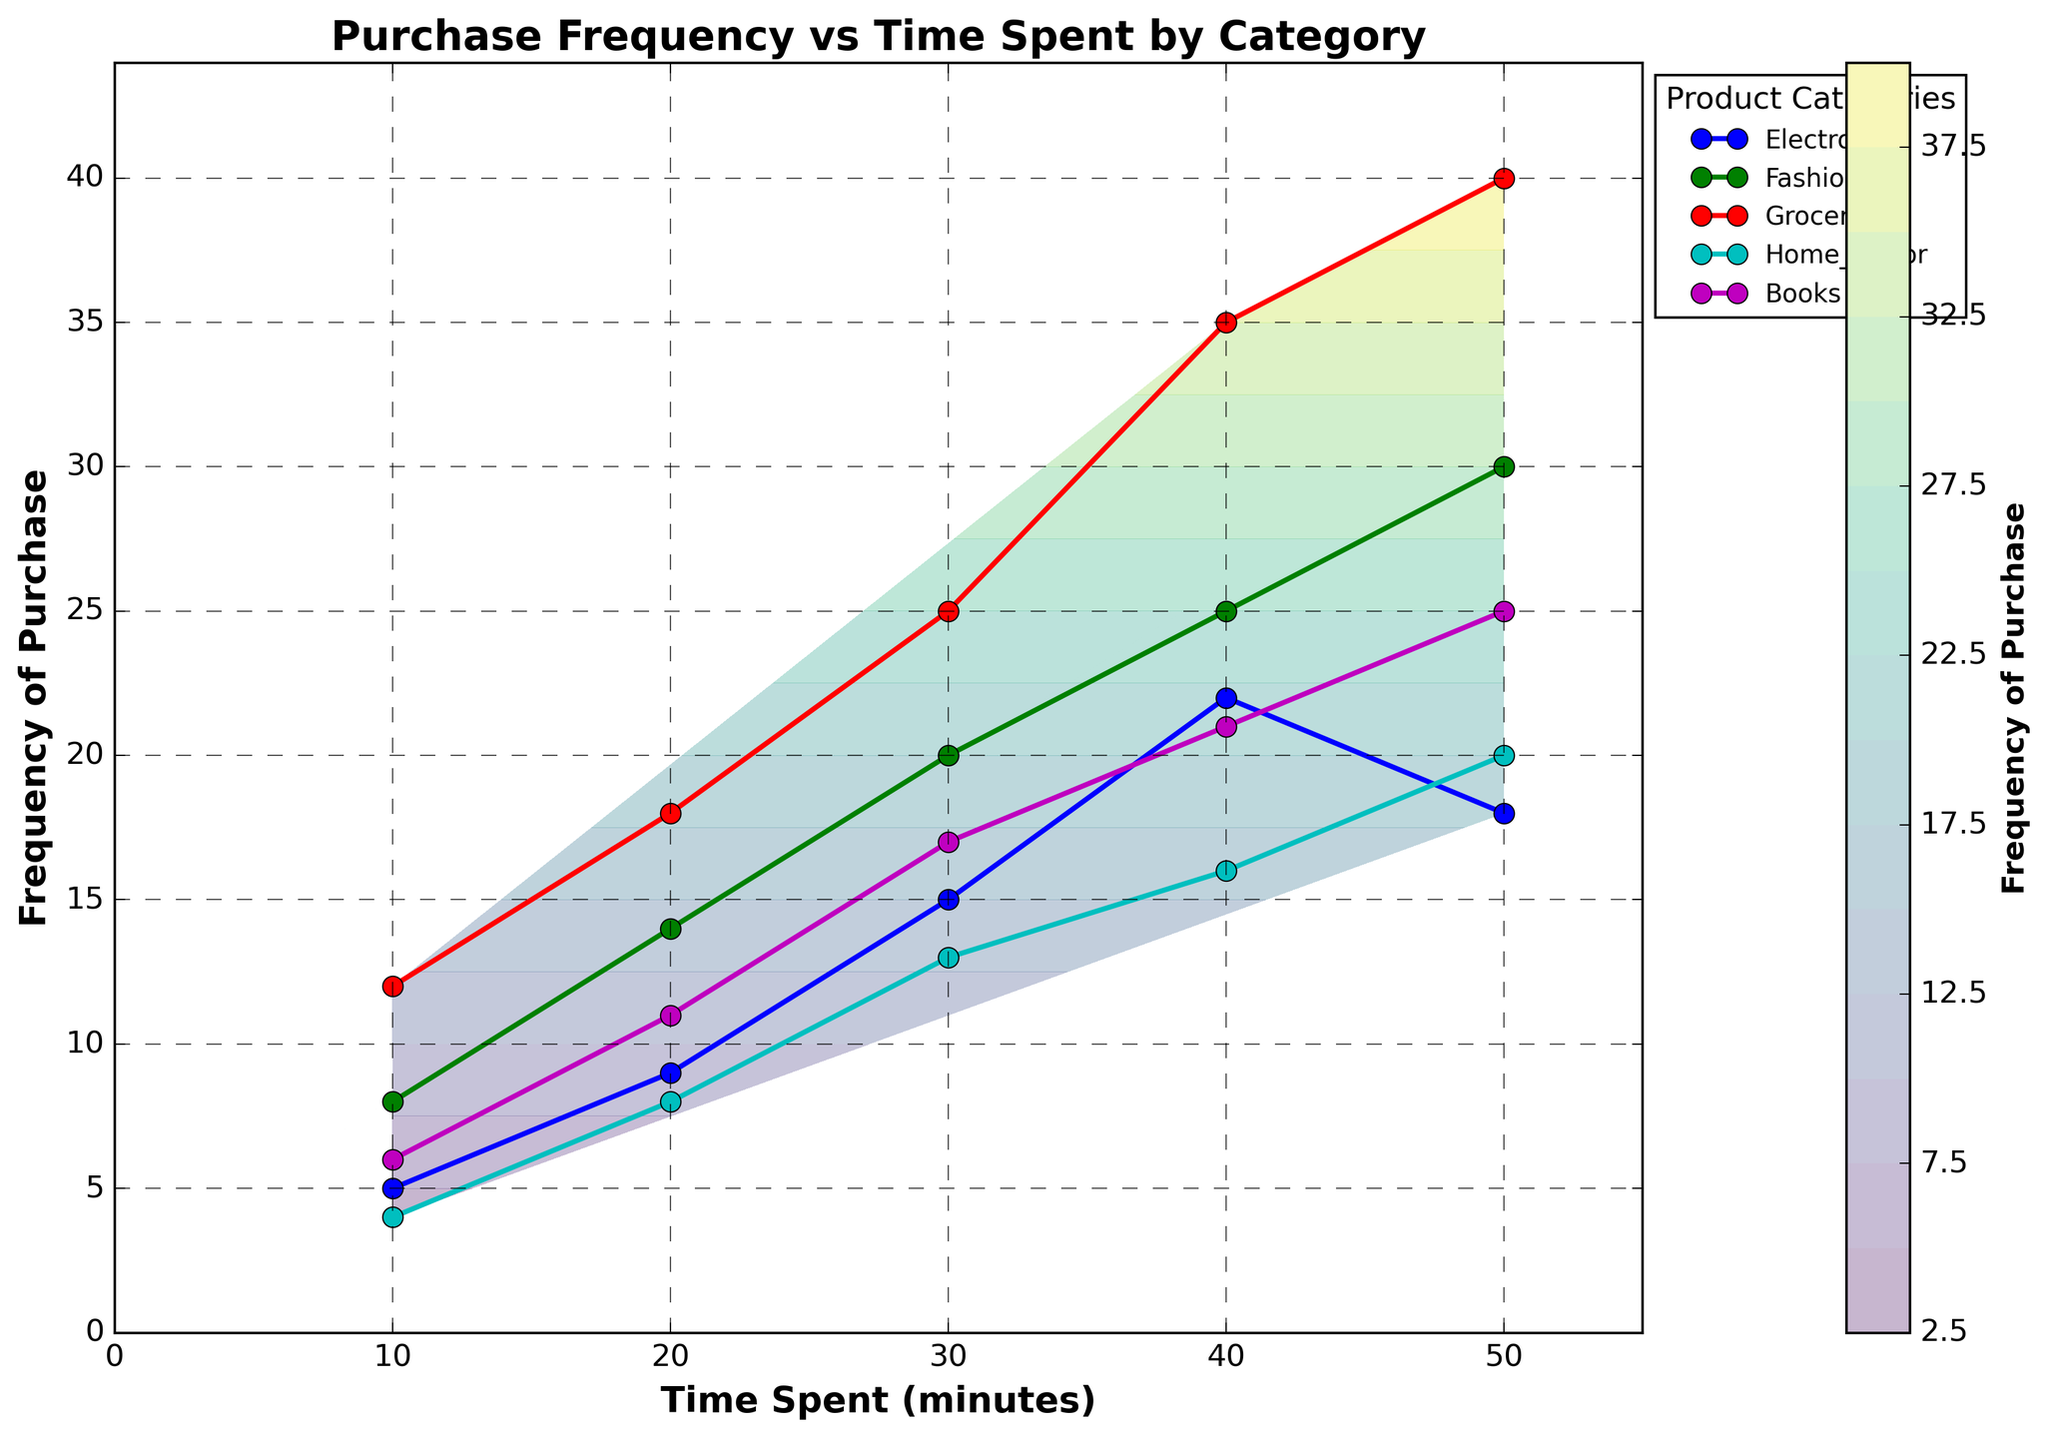What is the title of the plot? The title of the plot is usually placed at the top of the figure. Here, it reads "Purchase Frequency vs Time Spent by Category".
Answer: Purchase Frequency vs Time Spent by Category What are the axes labels? The axes labels are typically found alongside the horizontal and vertical axes. The x-axis label is "Time Spent (minutes)" and the y-axis label is "Frequency of Purchase".
Answer: Time Spent (minutes) and Frequency of Purchase Which purchase category shows the highest frequency of purchase as time spent increases? By observing the contour lines and data points, Groceries seem to have the highest frequency of purchase at each time interval. This is evident as Groceries have the topmost data points on the y-axis for large time values.
Answer: Groceries How does the frequency of purchase for Fashion compare to that of Electronics at 30 minutes? Identify the data points for Fashion and Electronics at the 30-minute mark. Fashion shows a frequency of 20, while Electronics shows a frequency of 15. By comparing these values, Fashion has a higher frequency than Electronics.
Answer: Fashion has a higher frequency What is the general trend of the frequency of purchase for all categories with respect to time spent on the website? Look at how the frequency changes as time increases for all categories. All categories show an upward trend indicating that the frequency of purchase increases with more time spent on the website.
Answer: Increases What is the difference in frequency of purchase between Groceries and Home Decor at 50 minutes? At 50 minutes, Groceries have a frequency of 40, while Home Decor has a frequency of 20. Subtract the frequency of Home Decor from that of Groceries (40 - 20).
Answer: 20 On the contour plot, which color represents the highest frequency of purchase? Contour plots use color gradients to represent different values. The color bar on the right indicates that shades near purple/blue represent lower frequencies, while shades near yellow/green indicate higher frequencies.
Answer: Yellow/Green Which category has the least frequency of purchase at 10 minutes? By inspecting the data points at the 10-minute mark for each category, Home Decor has the minimum frequency, which is 4.
Answer: Home Decor Can you identify any outliers in the data? Outliers are data points that significantly differ from others. The plotted data points and frequency values do not show significant deviations from their respective trends. Thus, there appear to be no outliers.
Answer: No outliers present 